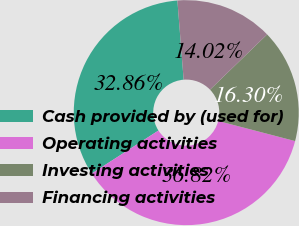Convert chart. <chart><loc_0><loc_0><loc_500><loc_500><pie_chart><fcel>Cash provided by (used for)<fcel>Operating activities<fcel>Investing activities<fcel>Financing activities<nl><fcel>32.86%<fcel>36.82%<fcel>16.3%<fcel>14.02%<nl></chart> 